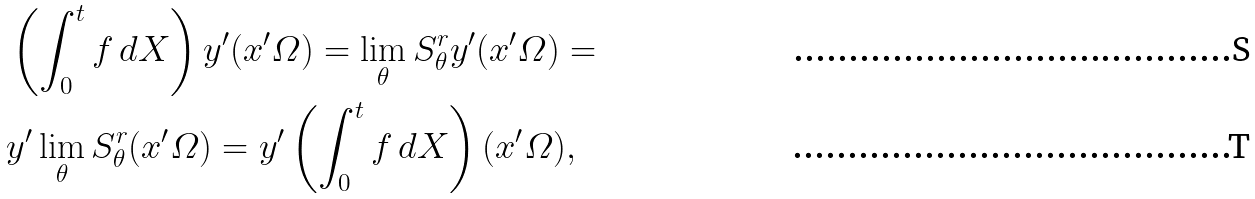<formula> <loc_0><loc_0><loc_500><loc_500>& \left ( \int _ { 0 } ^ { t } f \, d X \right ) y ^ { \prime } ( x ^ { \prime } \varOmega ) = \lim _ { \theta } S _ { \theta } ^ { r } y ^ { \prime } ( x ^ { \prime } \varOmega ) = \\ & y ^ { \prime } \lim _ { \theta } S _ { \theta } ^ { r } ( x ^ { \prime } \varOmega ) = y ^ { \prime } \left ( \int _ { 0 } ^ { t } f \, d X \right ) ( x ^ { \prime } \varOmega ) ,</formula> 